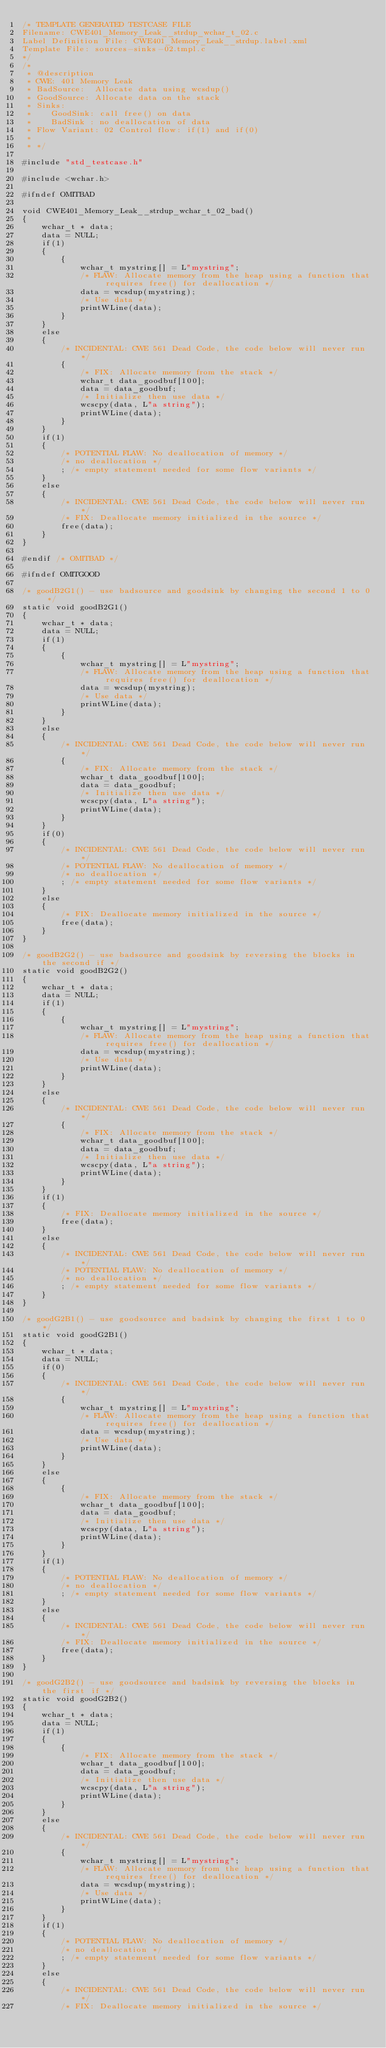<code> <loc_0><loc_0><loc_500><loc_500><_C_>/* TEMPLATE GENERATED TESTCASE FILE
Filename: CWE401_Memory_Leak__strdup_wchar_t_02.c
Label Definition File: CWE401_Memory_Leak__strdup.label.xml
Template File: sources-sinks-02.tmpl.c
*/
/*
 * @description
 * CWE: 401 Memory Leak
 * BadSource:  Allocate data using wcsdup()
 * GoodSource: Allocate data on the stack
 * Sinks:
 *    GoodSink: call free() on data
 *    BadSink : no deallocation of data
 * Flow Variant: 02 Control flow: if(1) and if(0)
 *
 * */

#include "std_testcase.h"

#include <wchar.h>

#ifndef OMITBAD

void CWE401_Memory_Leak__strdup_wchar_t_02_bad()
{
    wchar_t * data;
    data = NULL;
    if(1)
    {
        {
            wchar_t mystring[] = L"mystring";
            /* FLAW: Allocate memory from the heap using a function that requires free() for deallocation */
            data = wcsdup(mystring);
            /* Use data */
            printWLine(data);
        }
    }
    else
    {
        /* INCIDENTAL: CWE 561 Dead Code, the code below will never run */
        {
            /* FIX: Allocate memory from the stack */
            wchar_t data_goodbuf[100];
            data = data_goodbuf;
            /* Initialize then use data */
            wcscpy(data, L"a string");
            printWLine(data);
        }
    }
    if(1)
    {
        /* POTENTIAL FLAW: No deallocation of memory */
        /* no deallocation */
        ; /* empty statement needed for some flow variants */
    }
    else
    {
        /* INCIDENTAL: CWE 561 Dead Code, the code below will never run */
        /* FIX: Deallocate memory initialized in the source */
        free(data);
    }
}

#endif /* OMITBAD */

#ifndef OMITGOOD

/* goodB2G1() - use badsource and goodsink by changing the second 1 to 0 */
static void goodB2G1()
{
    wchar_t * data;
    data = NULL;
    if(1)
    {
        {
            wchar_t mystring[] = L"mystring";
            /* FLAW: Allocate memory from the heap using a function that requires free() for deallocation */
            data = wcsdup(mystring);
            /* Use data */
            printWLine(data);
        }
    }
    else
    {
        /* INCIDENTAL: CWE 561 Dead Code, the code below will never run */
        {
            /* FIX: Allocate memory from the stack */
            wchar_t data_goodbuf[100];
            data = data_goodbuf;
            /* Initialize then use data */
            wcscpy(data, L"a string");
            printWLine(data);
        }
    }
    if(0)
    {
        /* INCIDENTAL: CWE 561 Dead Code, the code below will never run */
        /* POTENTIAL FLAW: No deallocation of memory */
        /* no deallocation */
        ; /* empty statement needed for some flow variants */
    }
    else
    {
        /* FIX: Deallocate memory initialized in the source */
        free(data);
    }
}

/* goodB2G2() - use badsource and goodsink by reversing the blocks in the second if */
static void goodB2G2()
{
    wchar_t * data;
    data = NULL;
    if(1)
    {
        {
            wchar_t mystring[] = L"mystring";
            /* FLAW: Allocate memory from the heap using a function that requires free() for deallocation */
            data = wcsdup(mystring);
            /* Use data */
            printWLine(data);
        }
    }
    else
    {
        /* INCIDENTAL: CWE 561 Dead Code, the code below will never run */
        {
            /* FIX: Allocate memory from the stack */
            wchar_t data_goodbuf[100];
            data = data_goodbuf;
            /* Initialize then use data */
            wcscpy(data, L"a string");
            printWLine(data);
        }
    }
    if(1)
    {
        /* FIX: Deallocate memory initialized in the source */
        free(data);
    }
    else
    {
        /* INCIDENTAL: CWE 561 Dead Code, the code below will never run */
        /* POTENTIAL FLAW: No deallocation of memory */
        /* no deallocation */
        ; /* empty statement needed for some flow variants */
    }
}

/* goodG2B1() - use goodsource and badsink by changing the first 1 to 0 */
static void goodG2B1()
{
    wchar_t * data;
    data = NULL;
    if(0)
    {
        /* INCIDENTAL: CWE 561 Dead Code, the code below will never run */
        {
            wchar_t mystring[] = L"mystring";
            /* FLAW: Allocate memory from the heap using a function that requires free() for deallocation */
            data = wcsdup(mystring);
            /* Use data */
            printWLine(data);
        }
    }
    else
    {
        {
            /* FIX: Allocate memory from the stack */
            wchar_t data_goodbuf[100];
            data = data_goodbuf;
            /* Initialize then use data */
            wcscpy(data, L"a string");
            printWLine(data);
        }
    }
    if(1)
    {
        /* POTENTIAL FLAW: No deallocation of memory */
        /* no deallocation */
        ; /* empty statement needed for some flow variants */
    }
    else
    {
        /* INCIDENTAL: CWE 561 Dead Code, the code below will never run */
        /* FIX: Deallocate memory initialized in the source */
        free(data);
    }
}

/* goodG2B2() - use goodsource and badsink by reversing the blocks in the first if */
static void goodG2B2()
{
    wchar_t * data;
    data = NULL;
    if(1)
    {
        {
            /* FIX: Allocate memory from the stack */
            wchar_t data_goodbuf[100];
            data = data_goodbuf;
            /* Initialize then use data */
            wcscpy(data, L"a string");
            printWLine(data);
        }
    }
    else
    {
        /* INCIDENTAL: CWE 561 Dead Code, the code below will never run */
        {
            wchar_t mystring[] = L"mystring";
            /* FLAW: Allocate memory from the heap using a function that requires free() for deallocation */
            data = wcsdup(mystring);
            /* Use data */
            printWLine(data);
        }
    }
    if(1)
    {
        /* POTENTIAL FLAW: No deallocation of memory */
        /* no deallocation */
        ; /* empty statement needed for some flow variants */
    }
    else
    {
        /* INCIDENTAL: CWE 561 Dead Code, the code below will never run */
        /* FIX: Deallocate memory initialized in the source */</code> 